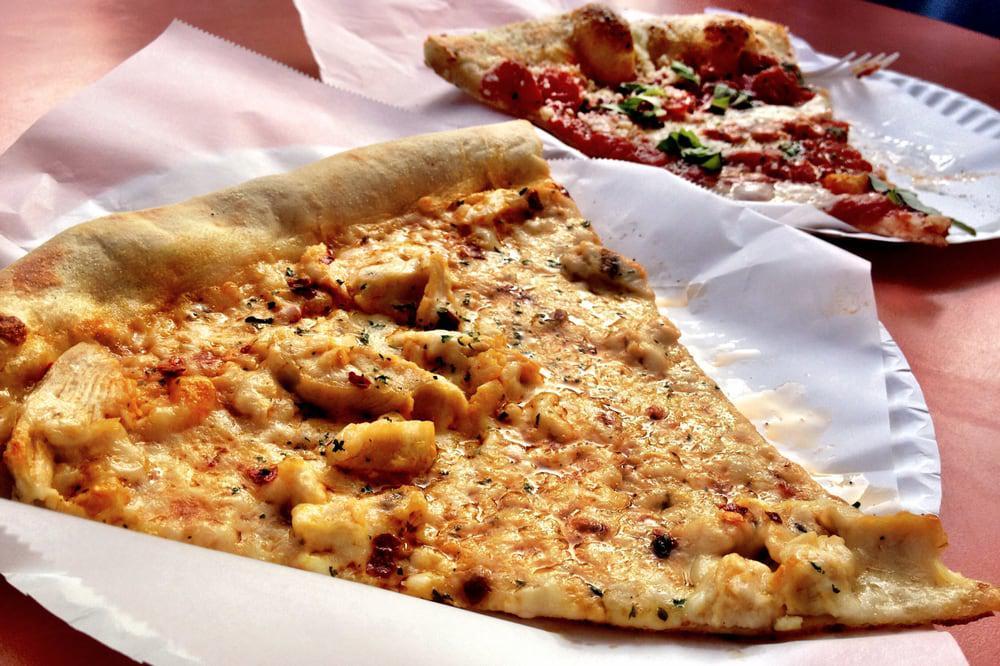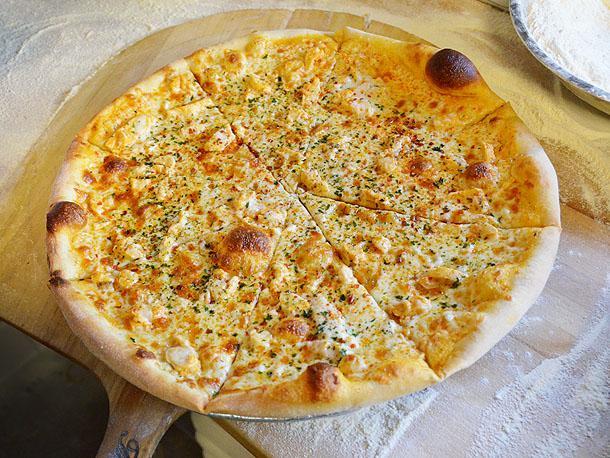The first image is the image on the left, the second image is the image on the right. Given the left and right images, does the statement "The left image shows at least one single slice of pizza." hold true? Answer yes or no. Yes. The first image is the image on the left, the second image is the image on the right. Given the left and right images, does the statement "The right image contains a sliced round pizza with no slices missing, and the left image contains at least one wedge-shaped slice of pizza on white paper." hold true? Answer yes or no. Yes. 